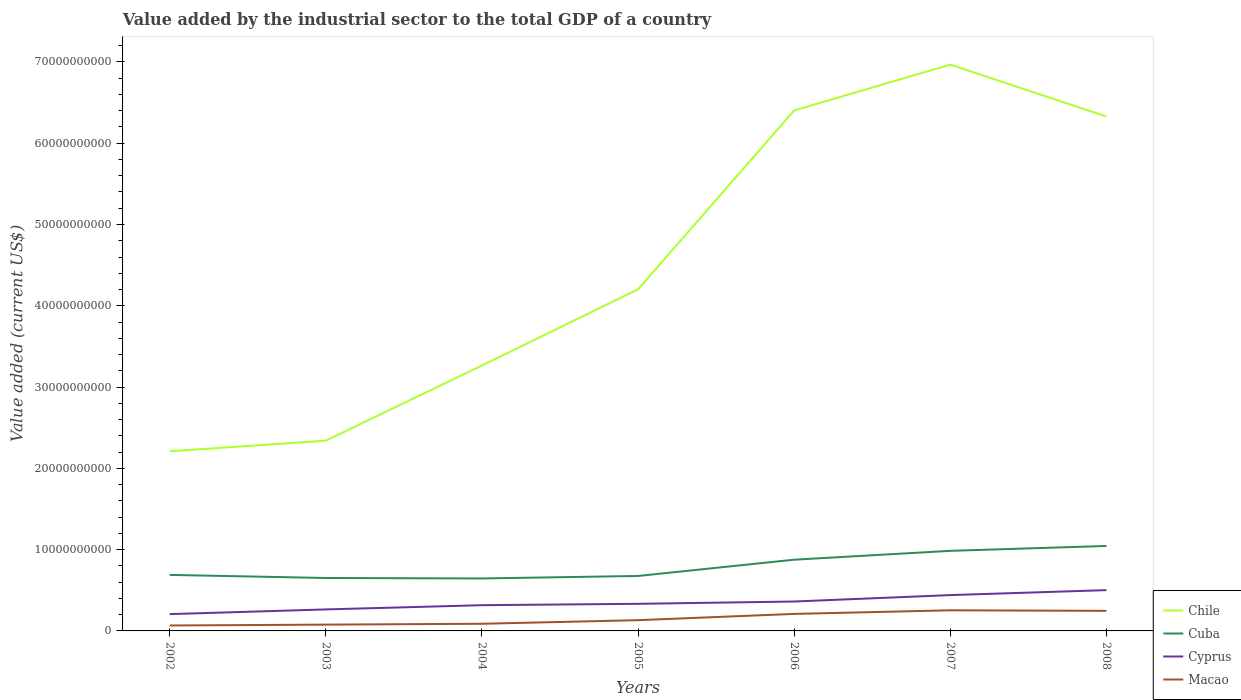Across all years, what is the maximum value added by the industrial sector to the total GDP in Cuba?
Your answer should be compact. 6.45e+09. What is the total value added by the industrial sector to the total GDP in Chile in the graph?
Your response must be concise. -3.70e+1. What is the difference between the highest and the second highest value added by the industrial sector to the total GDP in Cyprus?
Provide a short and direct response. 2.95e+09. What is the difference between the highest and the lowest value added by the industrial sector to the total GDP in Chile?
Provide a short and direct response. 3. Is the value added by the industrial sector to the total GDP in Cuba strictly greater than the value added by the industrial sector to the total GDP in Chile over the years?
Your answer should be compact. Yes. How many lines are there?
Offer a terse response. 4. How many years are there in the graph?
Keep it short and to the point. 7. What is the difference between two consecutive major ticks on the Y-axis?
Provide a short and direct response. 1.00e+1. Where does the legend appear in the graph?
Keep it short and to the point. Bottom right. How many legend labels are there?
Provide a succinct answer. 4. What is the title of the graph?
Provide a succinct answer. Value added by the industrial sector to the total GDP of a country. Does "Jamaica" appear as one of the legend labels in the graph?
Provide a succinct answer. No. What is the label or title of the Y-axis?
Your answer should be compact. Value added (current US$). What is the Value added (current US$) of Chile in 2002?
Give a very brief answer. 2.21e+1. What is the Value added (current US$) of Cuba in 2002?
Your answer should be very brief. 6.89e+09. What is the Value added (current US$) in Cyprus in 2002?
Offer a very short reply. 2.07e+09. What is the Value added (current US$) of Macao in 2002?
Your response must be concise. 6.69e+08. What is the Value added (current US$) of Chile in 2003?
Your answer should be compact. 2.34e+1. What is the Value added (current US$) of Cuba in 2003?
Make the answer very short. 6.51e+09. What is the Value added (current US$) of Cyprus in 2003?
Your answer should be very brief. 2.64e+09. What is the Value added (current US$) of Macao in 2003?
Provide a short and direct response. 7.75e+08. What is the Value added (current US$) of Chile in 2004?
Ensure brevity in your answer.  3.27e+1. What is the Value added (current US$) of Cuba in 2004?
Make the answer very short. 6.45e+09. What is the Value added (current US$) of Cyprus in 2004?
Your answer should be compact. 3.17e+09. What is the Value added (current US$) in Macao in 2004?
Provide a succinct answer. 8.80e+08. What is the Value added (current US$) in Chile in 2005?
Provide a short and direct response. 4.20e+1. What is the Value added (current US$) in Cuba in 2005?
Provide a short and direct response. 6.76e+09. What is the Value added (current US$) of Cyprus in 2005?
Your answer should be very brief. 3.34e+09. What is the Value added (current US$) of Macao in 2005?
Offer a terse response. 1.32e+09. What is the Value added (current US$) in Chile in 2006?
Provide a short and direct response. 6.40e+1. What is the Value added (current US$) of Cuba in 2006?
Your response must be concise. 8.76e+09. What is the Value added (current US$) in Cyprus in 2006?
Make the answer very short. 3.62e+09. What is the Value added (current US$) in Macao in 2006?
Provide a short and direct response. 2.09e+09. What is the Value added (current US$) of Chile in 2007?
Give a very brief answer. 6.97e+1. What is the Value added (current US$) in Cuba in 2007?
Make the answer very short. 9.85e+09. What is the Value added (current US$) of Cyprus in 2007?
Offer a terse response. 4.41e+09. What is the Value added (current US$) in Macao in 2007?
Your answer should be very brief. 2.54e+09. What is the Value added (current US$) of Chile in 2008?
Keep it short and to the point. 6.33e+1. What is the Value added (current US$) of Cuba in 2008?
Provide a succinct answer. 1.05e+1. What is the Value added (current US$) of Cyprus in 2008?
Ensure brevity in your answer.  5.02e+09. What is the Value added (current US$) of Macao in 2008?
Make the answer very short. 2.47e+09. Across all years, what is the maximum Value added (current US$) in Chile?
Give a very brief answer. 6.97e+1. Across all years, what is the maximum Value added (current US$) of Cuba?
Your answer should be very brief. 1.05e+1. Across all years, what is the maximum Value added (current US$) of Cyprus?
Ensure brevity in your answer.  5.02e+09. Across all years, what is the maximum Value added (current US$) in Macao?
Offer a very short reply. 2.54e+09. Across all years, what is the minimum Value added (current US$) in Chile?
Provide a short and direct response. 2.21e+1. Across all years, what is the minimum Value added (current US$) in Cuba?
Provide a succinct answer. 6.45e+09. Across all years, what is the minimum Value added (current US$) of Cyprus?
Your answer should be compact. 2.07e+09. Across all years, what is the minimum Value added (current US$) of Macao?
Your response must be concise. 6.69e+08. What is the total Value added (current US$) in Chile in the graph?
Offer a very short reply. 3.17e+11. What is the total Value added (current US$) in Cuba in the graph?
Ensure brevity in your answer.  5.57e+1. What is the total Value added (current US$) of Cyprus in the graph?
Your answer should be very brief. 2.43e+1. What is the total Value added (current US$) of Macao in the graph?
Keep it short and to the point. 1.07e+1. What is the difference between the Value added (current US$) in Chile in 2002 and that in 2003?
Give a very brief answer. -1.30e+09. What is the difference between the Value added (current US$) of Cuba in 2002 and that in 2003?
Offer a terse response. 3.80e+08. What is the difference between the Value added (current US$) of Cyprus in 2002 and that in 2003?
Make the answer very short. -5.78e+08. What is the difference between the Value added (current US$) of Macao in 2002 and that in 2003?
Provide a short and direct response. -1.06e+08. What is the difference between the Value added (current US$) in Chile in 2002 and that in 2004?
Keep it short and to the point. -1.06e+1. What is the difference between the Value added (current US$) in Cuba in 2002 and that in 2004?
Offer a terse response. 4.38e+08. What is the difference between the Value added (current US$) of Cyprus in 2002 and that in 2004?
Offer a terse response. -1.10e+09. What is the difference between the Value added (current US$) of Macao in 2002 and that in 2004?
Provide a succinct answer. -2.12e+08. What is the difference between the Value added (current US$) of Chile in 2002 and that in 2005?
Provide a short and direct response. -1.99e+1. What is the difference between the Value added (current US$) in Cuba in 2002 and that in 2005?
Make the answer very short. 1.31e+08. What is the difference between the Value added (current US$) in Cyprus in 2002 and that in 2005?
Your answer should be compact. -1.27e+09. What is the difference between the Value added (current US$) of Macao in 2002 and that in 2005?
Provide a short and direct response. -6.54e+08. What is the difference between the Value added (current US$) in Chile in 2002 and that in 2006?
Your answer should be very brief. -4.19e+1. What is the difference between the Value added (current US$) of Cuba in 2002 and that in 2006?
Offer a terse response. -1.87e+09. What is the difference between the Value added (current US$) of Cyprus in 2002 and that in 2006?
Give a very brief answer. -1.55e+09. What is the difference between the Value added (current US$) in Macao in 2002 and that in 2006?
Your response must be concise. -1.42e+09. What is the difference between the Value added (current US$) in Chile in 2002 and that in 2007?
Give a very brief answer. -4.76e+1. What is the difference between the Value added (current US$) of Cuba in 2002 and that in 2007?
Provide a succinct answer. -2.96e+09. What is the difference between the Value added (current US$) in Cyprus in 2002 and that in 2007?
Ensure brevity in your answer.  -2.34e+09. What is the difference between the Value added (current US$) of Macao in 2002 and that in 2007?
Your response must be concise. -1.87e+09. What is the difference between the Value added (current US$) of Chile in 2002 and that in 2008?
Your answer should be compact. -4.12e+1. What is the difference between the Value added (current US$) of Cuba in 2002 and that in 2008?
Give a very brief answer. -3.56e+09. What is the difference between the Value added (current US$) in Cyprus in 2002 and that in 2008?
Give a very brief answer. -2.95e+09. What is the difference between the Value added (current US$) of Macao in 2002 and that in 2008?
Give a very brief answer. -1.80e+09. What is the difference between the Value added (current US$) of Chile in 2003 and that in 2004?
Provide a short and direct response. -9.25e+09. What is the difference between the Value added (current US$) in Cuba in 2003 and that in 2004?
Make the answer very short. 5.70e+07. What is the difference between the Value added (current US$) in Cyprus in 2003 and that in 2004?
Offer a terse response. -5.21e+08. What is the difference between the Value added (current US$) of Macao in 2003 and that in 2004?
Offer a terse response. -1.05e+08. What is the difference between the Value added (current US$) in Chile in 2003 and that in 2005?
Ensure brevity in your answer.  -1.86e+1. What is the difference between the Value added (current US$) of Cuba in 2003 and that in 2005?
Your response must be concise. -2.50e+08. What is the difference between the Value added (current US$) in Cyprus in 2003 and that in 2005?
Keep it short and to the point. -6.91e+08. What is the difference between the Value added (current US$) in Macao in 2003 and that in 2005?
Your answer should be compact. -5.48e+08. What is the difference between the Value added (current US$) in Chile in 2003 and that in 2006?
Provide a succinct answer. -4.06e+1. What is the difference between the Value added (current US$) in Cuba in 2003 and that in 2006?
Offer a terse response. -2.25e+09. What is the difference between the Value added (current US$) in Cyprus in 2003 and that in 2006?
Offer a terse response. -9.73e+08. What is the difference between the Value added (current US$) of Macao in 2003 and that in 2006?
Provide a succinct answer. -1.32e+09. What is the difference between the Value added (current US$) of Chile in 2003 and that in 2007?
Provide a succinct answer. -4.63e+1. What is the difference between the Value added (current US$) of Cuba in 2003 and that in 2007?
Your answer should be very brief. -3.34e+09. What is the difference between the Value added (current US$) in Cyprus in 2003 and that in 2007?
Ensure brevity in your answer.  -1.76e+09. What is the difference between the Value added (current US$) in Macao in 2003 and that in 2007?
Provide a succinct answer. -1.76e+09. What is the difference between the Value added (current US$) in Chile in 2003 and that in 2008?
Offer a terse response. -3.99e+1. What is the difference between the Value added (current US$) of Cuba in 2003 and that in 2008?
Ensure brevity in your answer.  -3.94e+09. What is the difference between the Value added (current US$) of Cyprus in 2003 and that in 2008?
Give a very brief answer. -2.37e+09. What is the difference between the Value added (current US$) of Macao in 2003 and that in 2008?
Ensure brevity in your answer.  -1.70e+09. What is the difference between the Value added (current US$) of Chile in 2004 and that in 2005?
Your response must be concise. -9.37e+09. What is the difference between the Value added (current US$) of Cuba in 2004 and that in 2005?
Your answer should be compact. -3.07e+08. What is the difference between the Value added (current US$) of Cyprus in 2004 and that in 2005?
Provide a short and direct response. -1.69e+08. What is the difference between the Value added (current US$) of Macao in 2004 and that in 2005?
Your answer should be very brief. -4.43e+08. What is the difference between the Value added (current US$) of Chile in 2004 and that in 2006?
Provide a succinct answer. -3.14e+1. What is the difference between the Value added (current US$) of Cuba in 2004 and that in 2006?
Your answer should be very brief. -2.31e+09. What is the difference between the Value added (current US$) in Cyprus in 2004 and that in 2006?
Ensure brevity in your answer.  -4.51e+08. What is the difference between the Value added (current US$) in Macao in 2004 and that in 2006?
Provide a short and direct response. -1.21e+09. What is the difference between the Value added (current US$) in Chile in 2004 and that in 2007?
Make the answer very short. -3.70e+1. What is the difference between the Value added (current US$) in Cuba in 2004 and that in 2007?
Ensure brevity in your answer.  -3.40e+09. What is the difference between the Value added (current US$) in Cyprus in 2004 and that in 2007?
Your answer should be compact. -1.24e+09. What is the difference between the Value added (current US$) in Macao in 2004 and that in 2007?
Make the answer very short. -1.66e+09. What is the difference between the Value added (current US$) in Chile in 2004 and that in 2008?
Offer a very short reply. -3.06e+1. What is the difference between the Value added (current US$) of Cuba in 2004 and that in 2008?
Make the answer very short. -4.00e+09. What is the difference between the Value added (current US$) of Cyprus in 2004 and that in 2008?
Your answer should be very brief. -1.85e+09. What is the difference between the Value added (current US$) in Macao in 2004 and that in 2008?
Offer a very short reply. -1.59e+09. What is the difference between the Value added (current US$) in Chile in 2005 and that in 2006?
Your answer should be compact. -2.20e+1. What is the difference between the Value added (current US$) of Cuba in 2005 and that in 2006?
Offer a very short reply. -2.00e+09. What is the difference between the Value added (current US$) in Cyprus in 2005 and that in 2006?
Provide a succinct answer. -2.82e+08. What is the difference between the Value added (current US$) in Macao in 2005 and that in 2006?
Your response must be concise. -7.70e+08. What is the difference between the Value added (current US$) of Chile in 2005 and that in 2007?
Your response must be concise. -2.76e+1. What is the difference between the Value added (current US$) in Cuba in 2005 and that in 2007?
Give a very brief answer. -3.09e+09. What is the difference between the Value added (current US$) in Cyprus in 2005 and that in 2007?
Offer a terse response. -1.07e+09. What is the difference between the Value added (current US$) in Macao in 2005 and that in 2007?
Provide a succinct answer. -1.21e+09. What is the difference between the Value added (current US$) in Chile in 2005 and that in 2008?
Make the answer very short. -2.13e+1. What is the difference between the Value added (current US$) of Cuba in 2005 and that in 2008?
Offer a terse response. -3.69e+09. What is the difference between the Value added (current US$) in Cyprus in 2005 and that in 2008?
Ensure brevity in your answer.  -1.68e+09. What is the difference between the Value added (current US$) in Macao in 2005 and that in 2008?
Provide a short and direct response. -1.15e+09. What is the difference between the Value added (current US$) in Chile in 2006 and that in 2007?
Keep it short and to the point. -5.64e+09. What is the difference between the Value added (current US$) of Cuba in 2006 and that in 2007?
Keep it short and to the point. -1.09e+09. What is the difference between the Value added (current US$) in Cyprus in 2006 and that in 2007?
Offer a very short reply. -7.90e+08. What is the difference between the Value added (current US$) of Macao in 2006 and that in 2007?
Your response must be concise. -4.45e+08. What is the difference between the Value added (current US$) in Chile in 2006 and that in 2008?
Your answer should be very brief. 7.50e+08. What is the difference between the Value added (current US$) in Cuba in 2006 and that in 2008?
Make the answer very short. -1.69e+09. What is the difference between the Value added (current US$) in Cyprus in 2006 and that in 2008?
Provide a succinct answer. -1.40e+09. What is the difference between the Value added (current US$) of Macao in 2006 and that in 2008?
Offer a terse response. -3.78e+08. What is the difference between the Value added (current US$) of Chile in 2007 and that in 2008?
Your answer should be compact. 6.39e+09. What is the difference between the Value added (current US$) of Cuba in 2007 and that in 2008?
Offer a very short reply. -5.99e+08. What is the difference between the Value added (current US$) of Cyprus in 2007 and that in 2008?
Your answer should be compact. -6.11e+08. What is the difference between the Value added (current US$) in Macao in 2007 and that in 2008?
Your answer should be compact. 6.68e+07. What is the difference between the Value added (current US$) of Chile in 2002 and the Value added (current US$) of Cuba in 2003?
Offer a very short reply. 1.56e+1. What is the difference between the Value added (current US$) in Chile in 2002 and the Value added (current US$) in Cyprus in 2003?
Give a very brief answer. 1.95e+1. What is the difference between the Value added (current US$) in Chile in 2002 and the Value added (current US$) in Macao in 2003?
Ensure brevity in your answer.  2.13e+1. What is the difference between the Value added (current US$) in Cuba in 2002 and the Value added (current US$) in Cyprus in 2003?
Provide a succinct answer. 4.25e+09. What is the difference between the Value added (current US$) in Cuba in 2002 and the Value added (current US$) in Macao in 2003?
Keep it short and to the point. 6.12e+09. What is the difference between the Value added (current US$) of Cyprus in 2002 and the Value added (current US$) of Macao in 2003?
Your response must be concise. 1.29e+09. What is the difference between the Value added (current US$) in Chile in 2002 and the Value added (current US$) in Cuba in 2004?
Provide a short and direct response. 1.56e+1. What is the difference between the Value added (current US$) of Chile in 2002 and the Value added (current US$) of Cyprus in 2004?
Your answer should be compact. 1.89e+1. What is the difference between the Value added (current US$) in Chile in 2002 and the Value added (current US$) in Macao in 2004?
Your answer should be compact. 2.12e+1. What is the difference between the Value added (current US$) of Cuba in 2002 and the Value added (current US$) of Cyprus in 2004?
Provide a short and direct response. 3.73e+09. What is the difference between the Value added (current US$) of Cuba in 2002 and the Value added (current US$) of Macao in 2004?
Ensure brevity in your answer.  6.01e+09. What is the difference between the Value added (current US$) in Cyprus in 2002 and the Value added (current US$) in Macao in 2004?
Provide a short and direct response. 1.19e+09. What is the difference between the Value added (current US$) of Chile in 2002 and the Value added (current US$) of Cuba in 2005?
Your response must be concise. 1.53e+1. What is the difference between the Value added (current US$) of Chile in 2002 and the Value added (current US$) of Cyprus in 2005?
Make the answer very short. 1.88e+1. What is the difference between the Value added (current US$) in Chile in 2002 and the Value added (current US$) in Macao in 2005?
Provide a short and direct response. 2.08e+1. What is the difference between the Value added (current US$) of Cuba in 2002 and the Value added (current US$) of Cyprus in 2005?
Your answer should be compact. 3.56e+09. What is the difference between the Value added (current US$) in Cuba in 2002 and the Value added (current US$) in Macao in 2005?
Your answer should be very brief. 5.57e+09. What is the difference between the Value added (current US$) of Cyprus in 2002 and the Value added (current US$) of Macao in 2005?
Offer a terse response. 7.44e+08. What is the difference between the Value added (current US$) in Chile in 2002 and the Value added (current US$) in Cuba in 2006?
Your answer should be very brief. 1.33e+1. What is the difference between the Value added (current US$) in Chile in 2002 and the Value added (current US$) in Cyprus in 2006?
Your response must be concise. 1.85e+1. What is the difference between the Value added (current US$) in Chile in 2002 and the Value added (current US$) in Macao in 2006?
Give a very brief answer. 2.00e+1. What is the difference between the Value added (current US$) of Cuba in 2002 and the Value added (current US$) of Cyprus in 2006?
Your answer should be very brief. 3.27e+09. What is the difference between the Value added (current US$) in Cuba in 2002 and the Value added (current US$) in Macao in 2006?
Give a very brief answer. 4.80e+09. What is the difference between the Value added (current US$) in Cyprus in 2002 and the Value added (current US$) in Macao in 2006?
Provide a succinct answer. -2.56e+07. What is the difference between the Value added (current US$) of Chile in 2002 and the Value added (current US$) of Cuba in 2007?
Offer a terse response. 1.22e+1. What is the difference between the Value added (current US$) in Chile in 2002 and the Value added (current US$) in Cyprus in 2007?
Your response must be concise. 1.77e+1. What is the difference between the Value added (current US$) in Chile in 2002 and the Value added (current US$) in Macao in 2007?
Make the answer very short. 1.96e+1. What is the difference between the Value added (current US$) in Cuba in 2002 and the Value added (current US$) in Cyprus in 2007?
Your answer should be very brief. 2.48e+09. What is the difference between the Value added (current US$) of Cuba in 2002 and the Value added (current US$) of Macao in 2007?
Offer a very short reply. 4.35e+09. What is the difference between the Value added (current US$) of Cyprus in 2002 and the Value added (current US$) of Macao in 2007?
Provide a short and direct response. -4.70e+08. What is the difference between the Value added (current US$) in Chile in 2002 and the Value added (current US$) in Cuba in 2008?
Your response must be concise. 1.16e+1. What is the difference between the Value added (current US$) in Chile in 2002 and the Value added (current US$) in Cyprus in 2008?
Offer a very short reply. 1.71e+1. What is the difference between the Value added (current US$) of Chile in 2002 and the Value added (current US$) of Macao in 2008?
Ensure brevity in your answer.  1.96e+1. What is the difference between the Value added (current US$) of Cuba in 2002 and the Value added (current US$) of Cyprus in 2008?
Offer a very short reply. 1.87e+09. What is the difference between the Value added (current US$) in Cuba in 2002 and the Value added (current US$) in Macao in 2008?
Give a very brief answer. 4.42e+09. What is the difference between the Value added (current US$) of Cyprus in 2002 and the Value added (current US$) of Macao in 2008?
Offer a terse response. -4.03e+08. What is the difference between the Value added (current US$) of Chile in 2003 and the Value added (current US$) of Cuba in 2004?
Your response must be concise. 1.69e+1. What is the difference between the Value added (current US$) of Chile in 2003 and the Value added (current US$) of Cyprus in 2004?
Provide a short and direct response. 2.02e+1. What is the difference between the Value added (current US$) of Chile in 2003 and the Value added (current US$) of Macao in 2004?
Provide a succinct answer. 2.25e+1. What is the difference between the Value added (current US$) of Cuba in 2003 and the Value added (current US$) of Cyprus in 2004?
Keep it short and to the point. 3.35e+09. What is the difference between the Value added (current US$) of Cuba in 2003 and the Value added (current US$) of Macao in 2004?
Provide a succinct answer. 5.63e+09. What is the difference between the Value added (current US$) in Cyprus in 2003 and the Value added (current US$) in Macao in 2004?
Your answer should be compact. 1.76e+09. What is the difference between the Value added (current US$) in Chile in 2003 and the Value added (current US$) in Cuba in 2005?
Your answer should be compact. 1.66e+1. What is the difference between the Value added (current US$) in Chile in 2003 and the Value added (current US$) in Cyprus in 2005?
Make the answer very short. 2.01e+1. What is the difference between the Value added (current US$) in Chile in 2003 and the Value added (current US$) in Macao in 2005?
Your response must be concise. 2.21e+1. What is the difference between the Value added (current US$) in Cuba in 2003 and the Value added (current US$) in Cyprus in 2005?
Offer a very short reply. 3.18e+09. What is the difference between the Value added (current US$) in Cuba in 2003 and the Value added (current US$) in Macao in 2005?
Offer a very short reply. 5.19e+09. What is the difference between the Value added (current US$) in Cyprus in 2003 and the Value added (current US$) in Macao in 2005?
Your answer should be compact. 1.32e+09. What is the difference between the Value added (current US$) in Chile in 2003 and the Value added (current US$) in Cuba in 2006?
Your answer should be very brief. 1.46e+1. What is the difference between the Value added (current US$) of Chile in 2003 and the Value added (current US$) of Cyprus in 2006?
Offer a terse response. 1.98e+1. What is the difference between the Value added (current US$) of Chile in 2003 and the Value added (current US$) of Macao in 2006?
Offer a terse response. 2.13e+1. What is the difference between the Value added (current US$) of Cuba in 2003 and the Value added (current US$) of Cyprus in 2006?
Provide a short and direct response. 2.89e+09. What is the difference between the Value added (current US$) in Cuba in 2003 and the Value added (current US$) in Macao in 2006?
Keep it short and to the point. 4.42e+09. What is the difference between the Value added (current US$) of Cyprus in 2003 and the Value added (current US$) of Macao in 2006?
Keep it short and to the point. 5.52e+08. What is the difference between the Value added (current US$) of Chile in 2003 and the Value added (current US$) of Cuba in 2007?
Provide a short and direct response. 1.36e+1. What is the difference between the Value added (current US$) of Chile in 2003 and the Value added (current US$) of Cyprus in 2007?
Offer a very short reply. 1.90e+1. What is the difference between the Value added (current US$) in Chile in 2003 and the Value added (current US$) in Macao in 2007?
Your response must be concise. 2.09e+1. What is the difference between the Value added (current US$) in Cuba in 2003 and the Value added (current US$) in Cyprus in 2007?
Provide a short and direct response. 2.10e+09. What is the difference between the Value added (current US$) of Cuba in 2003 and the Value added (current US$) of Macao in 2007?
Make the answer very short. 3.97e+09. What is the difference between the Value added (current US$) of Cyprus in 2003 and the Value added (current US$) of Macao in 2007?
Offer a very short reply. 1.07e+08. What is the difference between the Value added (current US$) of Chile in 2003 and the Value added (current US$) of Cuba in 2008?
Your answer should be compact. 1.30e+1. What is the difference between the Value added (current US$) in Chile in 2003 and the Value added (current US$) in Cyprus in 2008?
Your response must be concise. 1.84e+1. What is the difference between the Value added (current US$) in Chile in 2003 and the Value added (current US$) in Macao in 2008?
Make the answer very short. 2.09e+1. What is the difference between the Value added (current US$) in Cuba in 2003 and the Value added (current US$) in Cyprus in 2008?
Ensure brevity in your answer.  1.49e+09. What is the difference between the Value added (current US$) in Cuba in 2003 and the Value added (current US$) in Macao in 2008?
Make the answer very short. 4.04e+09. What is the difference between the Value added (current US$) of Cyprus in 2003 and the Value added (current US$) of Macao in 2008?
Ensure brevity in your answer.  1.74e+08. What is the difference between the Value added (current US$) of Chile in 2004 and the Value added (current US$) of Cuba in 2005?
Make the answer very short. 2.59e+1. What is the difference between the Value added (current US$) of Chile in 2004 and the Value added (current US$) of Cyprus in 2005?
Provide a short and direct response. 2.93e+1. What is the difference between the Value added (current US$) in Chile in 2004 and the Value added (current US$) in Macao in 2005?
Provide a succinct answer. 3.13e+1. What is the difference between the Value added (current US$) in Cuba in 2004 and the Value added (current US$) in Cyprus in 2005?
Offer a terse response. 3.12e+09. What is the difference between the Value added (current US$) of Cuba in 2004 and the Value added (current US$) of Macao in 2005?
Offer a very short reply. 5.13e+09. What is the difference between the Value added (current US$) in Cyprus in 2004 and the Value added (current US$) in Macao in 2005?
Give a very brief answer. 1.84e+09. What is the difference between the Value added (current US$) of Chile in 2004 and the Value added (current US$) of Cuba in 2006?
Make the answer very short. 2.39e+1. What is the difference between the Value added (current US$) in Chile in 2004 and the Value added (current US$) in Cyprus in 2006?
Offer a very short reply. 2.90e+1. What is the difference between the Value added (current US$) in Chile in 2004 and the Value added (current US$) in Macao in 2006?
Your answer should be compact. 3.06e+1. What is the difference between the Value added (current US$) in Cuba in 2004 and the Value added (current US$) in Cyprus in 2006?
Your response must be concise. 2.84e+09. What is the difference between the Value added (current US$) in Cuba in 2004 and the Value added (current US$) in Macao in 2006?
Your answer should be compact. 4.36e+09. What is the difference between the Value added (current US$) in Cyprus in 2004 and the Value added (current US$) in Macao in 2006?
Make the answer very short. 1.07e+09. What is the difference between the Value added (current US$) of Chile in 2004 and the Value added (current US$) of Cuba in 2007?
Your response must be concise. 2.28e+1. What is the difference between the Value added (current US$) in Chile in 2004 and the Value added (current US$) in Cyprus in 2007?
Give a very brief answer. 2.82e+1. What is the difference between the Value added (current US$) in Chile in 2004 and the Value added (current US$) in Macao in 2007?
Give a very brief answer. 3.01e+1. What is the difference between the Value added (current US$) in Cuba in 2004 and the Value added (current US$) in Cyprus in 2007?
Provide a short and direct response. 2.05e+09. What is the difference between the Value added (current US$) of Cuba in 2004 and the Value added (current US$) of Macao in 2007?
Provide a succinct answer. 3.92e+09. What is the difference between the Value added (current US$) of Cyprus in 2004 and the Value added (current US$) of Macao in 2007?
Offer a terse response. 6.29e+08. What is the difference between the Value added (current US$) in Chile in 2004 and the Value added (current US$) in Cuba in 2008?
Your answer should be very brief. 2.22e+1. What is the difference between the Value added (current US$) of Chile in 2004 and the Value added (current US$) of Cyprus in 2008?
Provide a succinct answer. 2.76e+1. What is the difference between the Value added (current US$) in Chile in 2004 and the Value added (current US$) in Macao in 2008?
Offer a very short reply. 3.02e+1. What is the difference between the Value added (current US$) in Cuba in 2004 and the Value added (current US$) in Cyprus in 2008?
Provide a short and direct response. 1.44e+09. What is the difference between the Value added (current US$) of Cuba in 2004 and the Value added (current US$) of Macao in 2008?
Your answer should be very brief. 3.98e+09. What is the difference between the Value added (current US$) in Cyprus in 2004 and the Value added (current US$) in Macao in 2008?
Your response must be concise. 6.95e+08. What is the difference between the Value added (current US$) in Chile in 2005 and the Value added (current US$) in Cuba in 2006?
Your response must be concise. 3.33e+1. What is the difference between the Value added (current US$) of Chile in 2005 and the Value added (current US$) of Cyprus in 2006?
Your response must be concise. 3.84e+1. What is the difference between the Value added (current US$) of Chile in 2005 and the Value added (current US$) of Macao in 2006?
Your answer should be very brief. 3.99e+1. What is the difference between the Value added (current US$) in Cuba in 2005 and the Value added (current US$) in Cyprus in 2006?
Make the answer very short. 3.14e+09. What is the difference between the Value added (current US$) in Cuba in 2005 and the Value added (current US$) in Macao in 2006?
Ensure brevity in your answer.  4.67e+09. What is the difference between the Value added (current US$) in Cyprus in 2005 and the Value added (current US$) in Macao in 2006?
Your response must be concise. 1.24e+09. What is the difference between the Value added (current US$) in Chile in 2005 and the Value added (current US$) in Cuba in 2007?
Give a very brief answer. 3.22e+1. What is the difference between the Value added (current US$) in Chile in 2005 and the Value added (current US$) in Cyprus in 2007?
Your answer should be very brief. 3.76e+1. What is the difference between the Value added (current US$) of Chile in 2005 and the Value added (current US$) of Macao in 2007?
Give a very brief answer. 3.95e+1. What is the difference between the Value added (current US$) of Cuba in 2005 and the Value added (current US$) of Cyprus in 2007?
Ensure brevity in your answer.  2.35e+09. What is the difference between the Value added (current US$) in Cuba in 2005 and the Value added (current US$) in Macao in 2007?
Your response must be concise. 4.22e+09. What is the difference between the Value added (current US$) of Cyprus in 2005 and the Value added (current US$) of Macao in 2007?
Offer a terse response. 7.98e+08. What is the difference between the Value added (current US$) in Chile in 2005 and the Value added (current US$) in Cuba in 2008?
Offer a very short reply. 3.16e+1. What is the difference between the Value added (current US$) of Chile in 2005 and the Value added (current US$) of Cyprus in 2008?
Offer a very short reply. 3.70e+1. What is the difference between the Value added (current US$) of Chile in 2005 and the Value added (current US$) of Macao in 2008?
Your response must be concise. 3.96e+1. What is the difference between the Value added (current US$) of Cuba in 2005 and the Value added (current US$) of Cyprus in 2008?
Your answer should be very brief. 1.74e+09. What is the difference between the Value added (current US$) of Cuba in 2005 and the Value added (current US$) of Macao in 2008?
Keep it short and to the point. 4.29e+09. What is the difference between the Value added (current US$) of Cyprus in 2005 and the Value added (current US$) of Macao in 2008?
Your response must be concise. 8.65e+08. What is the difference between the Value added (current US$) in Chile in 2006 and the Value added (current US$) in Cuba in 2007?
Your answer should be compact. 5.42e+1. What is the difference between the Value added (current US$) in Chile in 2006 and the Value added (current US$) in Cyprus in 2007?
Your answer should be compact. 5.96e+1. What is the difference between the Value added (current US$) of Chile in 2006 and the Value added (current US$) of Macao in 2007?
Provide a short and direct response. 6.15e+1. What is the difference between the Value added (current US$) in Cuba in 2006 and the Value added (current US$) in Cyprus in 2007?
Keep it short and to the point. 4.35e+09. What is the difference between the Value added (current US$) in Cuba in 2006 and the Value added (current US$) in Macao in 2007?
Your answer should be very brief. 6.23e+09. What is the difference between the Value added (current US$) of Cyprus in 2006 and the Value added (current US$) of Macao in 2007?
Offer a terse response. 1.08e+09. What is the difference between the Value added (current US$) of Chile in 2006 and the Value added (current US$) of Cuba in 2008?
Provide a short and direct response. 5.36e+1. What is the difference between the Value added (current US$) of Chile in 2006 and the Value added (current US$) of Cyprus in 2008?
Your answer should be very brief. 5.90e+1. What is the difference between the Value added (current US$) of Chile in 2006 and the Value added (current US$) of Macao in 2008?
Make the answer very short. 6.16e+1. What is the difference between the Value added (current US$) in Cuba in 2006 and the Value added (current US$) in Cyprus in 2008?
Ensure brevity in your answer.  3.74e+09. What is the difference between the Value added (current US$) in Cuba in 2006 and the Value added (current US$) in Macao in 2008?
Provide a short and direct response. 6.29e+09. What is the difference between the Value added (current US$) of Cyprus in 2006 and the Value added (current US$) of Macao in 2008?
Give a very brief answer. 1.15e+09. What is the difference between the Value added (current US$) of Chile in 2007 and the Value added (current US$) of Cuba in 2008?
Give a very brief answer. 5.92e+1. What is the difference between the Value added (current US$) in Chile in 2007 and the Value added (current US$) in Cyprus in 2008?
Provide a succinct answer. 6.46e+1. What is the difference between the Value added (current US$) in Chile in 2007 and the Value added (current US$) in Macao in 2008?
Keep it short and to the point. 6.72e+1. What is the difference between the Value added (current US$) in Cuba in 2007 and the Value added (current US$) in Cyprus in 2008?
Give a very brief answer. 4.83e+09. What is the difference between the Value added (current US$) in Cuba in 2007 and the Value added (current US$) in Macao in 2008?
Keep it short and to the point. 7.38e+09. What is the difference between the Value added (current US$) in Cyprus in 2007 and the Value added (current US$) in Macao in 2008?
Offer a terse response. 1.94e+09. What is the average Value added (current US$) of Chile per year?
Your response must be concise. 4.53e+1. What is the average Value added (current US$) in Cuba per year?
Offer a very short reply. 7.96e+09. What is the average Value added (current US$) of Cyprus per year?
Provide a succinct answer. 3.47e+09. What is the average Value added (current US$) in Macao per year?
Your answer should be very brief. 1.54e+09. In the year 2002, what is the difference between the Value added (current US$) in Chile and Value added (current US$) in Cuba?
Ensure brevity in your answer.  1.52e+1. In the year 2002, what is the difference between the Value added (current US$) in Chile and Value added (current US$) in Cyprus?
Keep it short and to the point. 2.00e+1. In the year 2002, what is the difference between the Value added (current US$) in Chile and Value added (current US$) in Macao?
Make the answer very short. 2.14e+1. In the year 2002, what is the difference between the Value added (current US$) in Cuba and Value added (current US$) in Cyprus?
Provide a short and direct response. 4.83e+09. In the year 2002, what is the difference between the Value added (current US$) in Cuba and Value added (current US$) in Macao?
Offer a very short reply. 6.22e+09. In the year 2002, what is the difference between the Value added (current US$) of Cyprus and Value added (current US$) of Macao?
Make the answer very short. 1.40e+09. In the year 2003, what is the difference between the Value added (current US$) of Chile and Value added (current US$) of Cuba?
Make the answer very short. 1.69e+1. In the year 2003, what is the difference between the Value added (current US$) in Chile and Value added (current US$) in Cyprus?
Offer a terse response. 2.08e+1. In the year 2003, what is the difference between the Value added (current US$) of Chile and Value added (current US$) of Macao?
Your answer should be very brief. 2.26e+1. In the year 2003, what is the difference between the Value added (current US$) of Cuba and Value added (current US$) of Cyprus?
Your answer should be very brief. 3.87e+09. In the year 2003, what is the difference between the Value added (current US$) in Cuba and Value added (current US$) in Macao?
Keep it short and to the point. 5.74e+09. In the year 2003, what is the difference between the Value added (current US$) in Cyprus and Value added (current US$) in Macao?
Ensure brevity in your answer.  1.87e+09. In the year 2004, what is the difference between the Value added (current US$) in Chile and Value added (current US$) in Cuba?
Ensure brevity in your answer.  2.62e+1. In the year 2004, what is the difference between the Value added (current US$) in Chile and Value added (current US$) in Cyprus?
Offer a very short reply. 2.95e+1. In the year 2004, what is the difference between the Value added (current US$) in Chile and Value added (current US$) in Macao?
Provide a succinct answer. 3.18e+1. In the year 2004, what is the difference between the Value added (current US$) in Cuba and Value added (current US$) in Cyprus?
Ensure brevity in your answer.  3.29e+09. In the year 2004, what is the difference between the Value added (current US$) of Cuba and Value added (current US$) of Macao?
Keep it short and to the point. 5.57e+09. In the year 2004, what is the difference between the Value added (current US$) in Cyprus and Value added (current US$) in Macao?
Your answer should be compact. 2.29e+09. In the year 2005, what is the difference between the Value added (current US$) of Chile and Value added (current US$) of Cuba?
Offer a terse response. 3.53e+1. In the year 2005, what is the difference between the Value added (current US$) of Chile and Value added (current US$) of Cyprus?
Make the answer very short. 3.87e+1. In the year 2005, what is the difference between the Value added (current US$) in Chile and Value added (current US$) in Macao?
Your answer should be compact. 4.07e+1. In the year 2005, what is the difference between the Value added (current US$) of Cuba and Value added (current US$) of Cyprus?
Offer a terse response. 3.43e+09. In the year 2005, what is the difference between the Value added (current US$) in Cuba and Value added (current US$) in Macao?
Provide a short and direct response. 5.44e+09. In the year 2005, what is the difference between the Value added (current US$) of Cyprus and Value added (current US$) of Macao?
Provide a succinct answer. 2.01e+09. In the year 2006, what is the difference between the Value added (current US$) in Chile and Value added (current US$) in Cuba?
Your response must be concise. 5.53e+1. In the year 2006, what is the difference between the Value added (current US$) in Chile and Value added (current US$) in Cyprus?
Offer a terse response. 6.04e+1. In the year 2006, what is the difference between the Value added (current US$) in Chile and Value added (current US$) in Macao?
Make the answer very short. 6.19e+1. In the year 2006, what is the difference between the Value added (current US$) in Cuba and Value added (current US$) in Cyprus?
Provide a short and direct response. 5.15e+09. In the year 2006, what is the difference between the Value added (current US$) in Cuba and Value added (current US$) in Macao?
Keep it short and to the point. 6.67e+09. In the year 2006, what is the difference between the Value added (current US$) in Cyprus and Value added (current US$) in Macao?
Offer a very short reply. 1.52e+09. In the year 2007, what is the difference between the Value added (current US$) of Chile and Value added (current US$) of Cuba?
Your response must be concise. 5.98e+1. In the year 2007, what is the difference between the Value added (current US$) in Chile and Value added (current US$) in Cyprus?
Ensure brevity in your answer.  6.53e+1. In the year 2007, what is the difference between the Value added (current US$) in Chile and Value added (current US$) in Macao?
Keep it short and to the point. 6.71e+1. In the year 2007, what is the difference between the Value added (current US$) of Cuba and Value added (current US$) of Cyprus?
Make the answer very short. 5.44e+09. In the year 2007, what is the difference between the Value added (current US$) in Cuba and Value added (current US$) in Macao?
Your response must be concise. 7.31e+09. In the year 2007, what is the difference between the Value added (current US$) in Cyprus and Value added (current US$) in Macao?
Provide a short and direct response. 1.87e+09. In the year 2008, what is the difference between the Value added (current US$) of Chile and Value added (current US$) of Cuba?
Provide a succinct answer. 5.28e+1. In the year 2008, what is the difference between the Value added (current US$) in Chile and Value added (current US$) in Cyprus?
Make the answer very short. 5.83e+1. In the year 2008, what is the difference between the Value added (current US$) of Chile and Value added (current US$) of Macao?
Make the answer very short. 6.08e+1. In the year 2008, what is the difference between the Value added (current US$) in Cuba and Value added (current US$) in Cyprus?
Provide a succinct answer. 5.43e+09. In the year 2008, what is the difference between the Value added (current US$) in Cuba and Value added (current US$) in Macao?
Keep it short and to the point. 7.98e+09. In the year 2008, what is the difference between the Value added (current US$) of Cyprus and Value added (current US$) of Macao?
Make the answer very short. 2.55e+09. What is the ratio of the Value added (current US$) in Chile in 2002 to that in 2003?
Ensure brevity in your answer.  0.94. What is the ratio of the Value added (current US$) in Cuba in 2002 to that in 2003?
Your response must be concise. 1.06. What is the ratio of the Value added (current US$) in Cyprus in 2002 to that in 2003?
Your answer should be compact. 0.78. What is the ratio of the Value added (current US$) of Macao in 2002 to that in 2003?
Offer a very short reply. 0.86. What is the ratio of the Value added (current US$) of Chile in 2002 to that in 2004?
Give a very brief answer. 0.68. What is the ratio of the Value added (current US$) of Cuba in 2002 to that in 2004?
Your answer should be very brief. 1.07. What is the ratio of the Value added (current US$) of Cyprus in 2002 to that in 2004?
Ensure brevity in your answer.  0.65. What is the ratio of the Value added (current US$) in Macao in 2002 to that in 2004?
Offer a very short reply. 0.76. What is the ratio of the Value added (current US$) in Chile in 2002 to that in 2005?
Offer a terse response. 0.53. What is the ratio of the Value added (current US$) of Cuba in 2002 to that in 2005?
Keep it short and to the point. 1.02. What is the ratio of the Value added (current US$) of Cyprus in 2002 to that in 2005?
Offer a terse response. 0.62. What is the ratio of the Value added (current US$) in Macao in 2002 to that in 2005?
Your answer should be very brief. 0.51. What is the ratio of the Value added (current US$) of Chile in 2002 to that in 2006?
Provide a short and direct response. 0.35. What is the ratio of the Value added (current US$) in Cuba in 2002 to that in 2006?
Offer a terse response. 0.79. What is the ratio of the Value added (current US$) in Macao in 2002 to that in 2006?
Give a very brief answer. 0.32. What is the ratio of the Value added (current US$) of Chile in 2002 to that in 2007?
Offer a very short reply. 0.32. What is the ratio of the Value added (current US$) in Cuba in 2002 to that in 2007?
Your answer should be very brief. 0.7. What is the ratio of the Value added (current US$) of Cyprus in 2002 to that in 2007?
Ensure brevity in your answer.  0.47. What is the ratio of the Value added (current US$) of Macao in 2002 to that in 2007?
Your answer should be compact. 0.26. What is the ratio of the Value added (current US$) in Chile in 2002 to that in 2008?
Offer a very short reply. 0.35. What is the ratio of the Value added (current US$) of Cuba in 2002 to that in 2008?
Offer a terse response. 0.66. What is the ratio of the Value added (current US$) of Cyprus in 2002 to that in 2008?
Ensure brevity in your answer.  0.41. What is the ratio of the Value added (current US$) in Macao in 2002 to that in 2008?
Offer a terse response. 0.27. What is the ratio of the Value added (current US$) of Chile in 2003 to that in 2004?
Your answer should be compact. 0.72. What is the ratio of the Value added (current US$) in Cuba in 2003 to that in 2004?
Provide a short and direct response. 1.01. What is the ratio of the Value added (current US$) in Cyprus in 2003 to that in 2004?
Make the answer very short. 0.84. What is the ratio of the Value added (current US$) of Macao in 2003 to that in 2004?
Your answer should be compact. 0.88. What is the ratio of the Value added (current US$) of Chile in 2003 to that in 2005?
Ensure brevity in your answer.  0.56. What is the ratio of the Value added (current US$) in Cuba in 2003 to that in 2005?
Provide a succinct answer. 0.96. What is the ratio of the Value added (current US$) in Cyprus in 2003 to that in 2005?
Make the answer very short. 0.79. What is the ratio of the Value added (current US$) of Macao in 2003 to that in 2005?
Provide a short and direct response. 0.59. What is the ratio of the Value added (current US$) of Chile in 2003 to that in 2006?
Offer a terse response. 0.37. What is the ratio of the Value added (current US$) in Cuba in 2003 to that in 2006?
Keep it short and to the point. 0.74. What is the ratio of the Value added (current US$) of Cyprus in 2003 to that in 2006?
Make the answer very short. 0.73. What is the ratio of the Value added (current US$) in Macao in 2003 to that in 2006?
Ensure brevity in your answer.  0.37. What is the ratio of the Value added (current US$) of Chile in 2003 to that in 2007?
Your answer should be compact. 0.34. What is the ratio of the Value added (current US$) of Cuba in 2003 to that in 2007?
Your answer should be very brief. 0.66. What is the ratio of the Value added (current US$) in Cyprus in 2003 to that in 2007?
Offer a very short reply. 0.6. What is the ratio of the Value added (current US$) of Macao in 2003 to that in 2007?
Provide a succinct answer. 0.31. What is the ratio of the Value added (current US$) of Chile in 2003 to that in 2008?
Make the answer very short. 0.37. What is the ratio of the Value added (current US$) in Cuba in 2003 to that in 2008?
Offer a very short reply. 0.62. What is the ratio of the Value added (current US$) in Cyprus in 2003 to that in 2008?
Make the answer very short. 0.53. What is the ratio of the Value added (current US$) in Macao in 2003 to that in 2008?
Give a very brief answer. 0.31. What is the ratio of the Value added (current US$) of Chile in 2004 to that in 2005?
Make the answer very short. 0.78. What is the ratio of the Value added (current US$) in Cuba in 2004 to that in 2005?
Keep it short and to the point. 0.95. What is the ratio of the Value added (current US$) of Cyprus in 2004 to that in 2005?
Provide a short and direct response. 0.95. What is the ratio of the Value added (current US$) of Macao in 2004 to that in 2005?
Make the answer very short. 0.67. What is the ratio of the Value added (current US$) of Chile in 2004 to that in 2006?
Provide a succinct answer. 0.51. What is the ratio of the Value added (current US$) of Cuba in 2004 to that in 2006?
Keep it short and to the point. 0.74. What is the ratio of the Value added (current US$) in Cyprus in 2004 to that in 2006?
Your answer should be compact. 0.88. What is the ratio of the Value added (current US$) in Macao in 2004 to that in 2006?
Give a very brief answer. 0.42. What is the ratio of the Value added (current US$) of Chile in 2004 to that in 2007?
Make the answer very short. 0.47. What is the ratio of the Value added (current US$) of Cuba in 2004 to that in 2007?
Provide a succinct answer. 0.66. What is the ratio of the Value added (current US$) of Cyprus in 2004 to that in 2007?
Ensure brevity in your answer.  0.72. What is the ratio of the Value added (current US$) of Macao in 2004 to that in 2007?
Offer a very short reply. 0.35. What is the ratio of the Value added (current US$) in Chile in 2004 to that in 2008?
Offer a terse response. 0.52. What is the ratio of the Value added (current US$) of Cuba in 2004 to that in 2008?
Offer a terse response. 0.62. What is the ratio of the Value added (current US$) of Cyprus in 2004 to that in 2008?
Offer a very short reply. 0.63. What is the ratio of the Value added (current US$) of Macao in 2004 to that in 2008?
Offer a very short reply. 0.36. What is the ratio of the Value added (current US$) of Chile in 2005 to that in 2006?
Offer a terse response. 0.66. What is the ratio of the Value added (current US$) in Cuba in 2005 to that in 2006?
Your answer should be compact. 0.77. What is the ratio of the Value added (current US$) in Cyprus in 2005 to that in 2006?
Your response must be concise. 0.92. What is the ratio of the Value added (current US$) in Macao in 2005 to that in 2006?
Provide a succinct answer. 0.63. What is the ratio of the Value added (current US$) of Chile in 2005 to that in 2007?
Your answer should be very brief. 0.6. What is the ratio of the Value added (current US$) in Cuba in 2005 to that in 2007?
Your answer should be very brief. 0.69. What is the ratio of the Value added (current US$) in Cyprus in 2005 to that in 2007?
Your answer should be compact. 0.76. What is the ratio of the Value added (current US$) of Macao in 2005 to that in 2007?
Make the answer very short. 0.52. What is the ratio of the Value added (current US$) of Chile in 2005 to that in 2008?
Make the answer very short. 0.66. What is the ratio of the Value added (current US$) of Cuba in 2005 to that in 2008?
Make the answer very short. 0.65. What is the ratio of the Value added (current US$) in Cyprus in 2005 to that in 2008?
Offer a terse response. 0.66. What is the ratio of the Value added (current US$) of Macao in 2005 to that in 2008?
Keep it short and to the point. 0.54. What is the ratio of the Value added (current US$) of Chile in 2006 to that in 2007?
Give a very brief answer. 0.92. What is the ratio of the Value added (current US$) of Cuba in 2006 to that in 2007?
Offer a very short reply. 0.89. What is the ratio of the Value added (current US$) in Cyprus in 2006 to that in 2007?
Give a very brief answer. 0.82. What is the ratio of the Value added (current US$) of Macao in 2006 to that in 2007?
Give a very brief answer. 0.82. What is the ratio of the Value added (current US$) in Chile in 2006 to that in 2008?
Give a very brief answer. 1.01. What is the ratio of the Value added (current US$) in Cuba in 2006 to that in 2008?
Give a very brief answer. 0.84. What is the ratio of the Value added (current US$) in Cyprus in 2006 to that in 2008?
Offer a terse response. 0.72. What is the ratio of the Value added (current US$) of Macao in 2006 to that in 2008?
Make the answer very short. 0.85. What is the ratio of the Value added (current US$) of Chile in 2007 to that in 2008?
Offer a terse response. 1.1. What is the ratio of the Value added (current US$) of Cuba in 2007 to that in 2008?
Your response must be concise. 0.94. What is the ratio of the Value added (current US$) in Cyprus in 2007 to that in 2008?
Offer a terse response. 0.88. What is the ratio of the Value added (current US$) in Macao in 2007 to that in 2008?
Offer a terse response. 1.03. What is the difference between the highest and the second highest Value added (current US$) in Chile?
Give a very brief answer. 5.64e+09. What is the difference between the highest and the second highest Value added (current US$) in Cuba?
Keep it short and to the point. 5.99e+08. What is the difference between the highest and the second highest Value added (current US$) in Cyprus?
Offer a terse response. 6.11e+08. What is the difference between the highest and the second highest Value added (current US$) in Macao?
Provide a short and direct response. 6.68e+07. What is the difference between the highest and the lowest Value added (current US$) in Chile?
Provide a short and direct response. 4.76e+1. What is the difference between the highest and the lowest Value added (current US$) of Cuba?
Offer a terse response. 4.00e+09. What is the difference between the highest and the lowest Value added (current US$) in Cyprus?
Keep it short and to the point. 2.95e+09. What is the difference between the highest and the lowest Value added (current US$) in Macao?
Offer a terse response. 1.87e+09. 